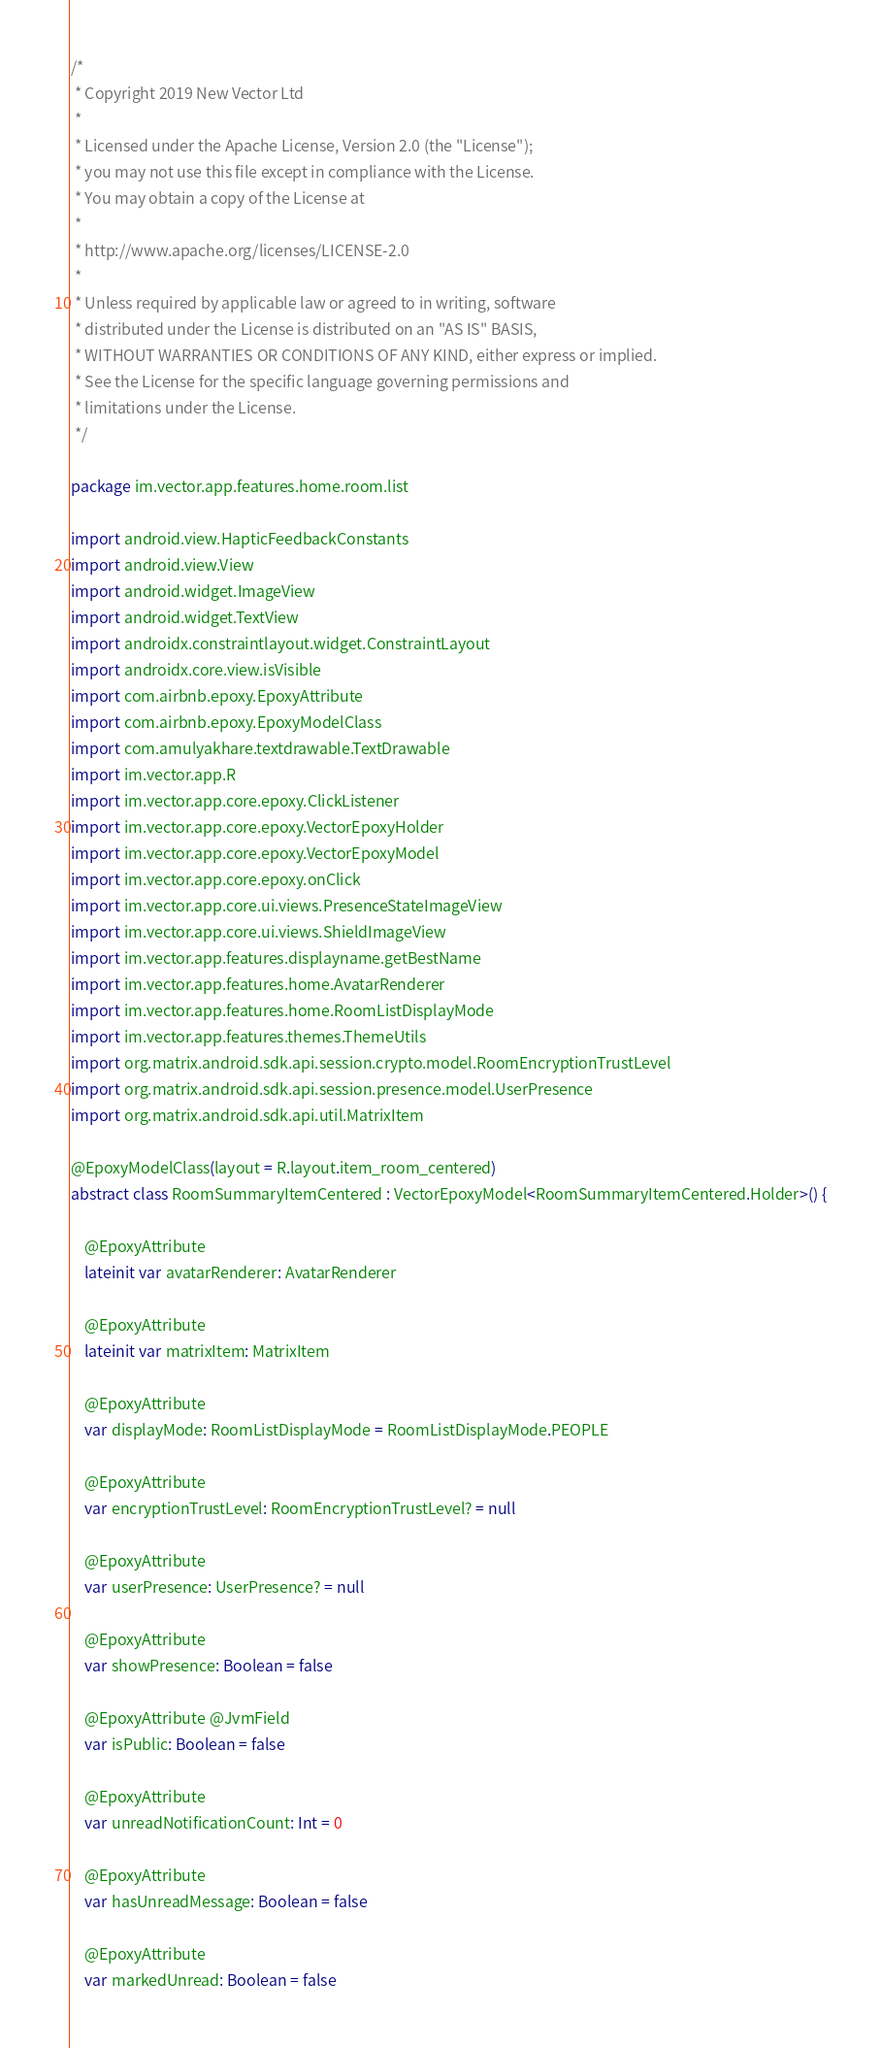<code> <loc_0><loc_0><loc_500><loc_500><_Kotlin_>/*
 * Copyright 2019 New Vector Ltd
 *
 * Licensed under the Apache License, Version 2.0 (the "License");
 * you may not use this file except in compliance with the License.
 * You may obtain a copy of the License at
 *
 * http://www.apache.org/licenses/LICENSE-2.0
 *
 * Unless required by applicable law or agreed to in writing, software
 * distributed under the License is distributed on an "AS IS" BASIS,
 * WITHOUT WARRANTIES OR CONDITIONS OF ANY KIND, either express or implied.
 * See the License for the specific language governing permissions and
 * limitations under the License.
 */

package im.vector.app.features.home.room.list

import android.view.HapticFeedbackConstants
import android.view.View
import android.widget.ImageView
import android.widget.TextView
import androidx.constraintlayout.widget.ConstraintLayout
import androidx.core.view.isVisible
import com.airbnb.epoxy.EpoxyAttribute
import com.airbnb.epoxy.EpoxyModelClass
import com.amulyakhare.textdrawable.TextDrawable
import im.vector.app.R
import im.vector.app.core.epoxy.ClickListener
import im.vector.app.core.epoxy.VectorEpoxyHolder
import im.vector.app.core.epoxy.VectorEpoxyModel
import im.vector.app.core.epoxy.onClick
import im.vector.app.core.ui.views.PresenceStateImageView
import im.vector.app.core.ui.views.ShieldImageView
import im.vector.app.features.displayname.getBestName
import im.vector.app.features.home.AvatarRenderer
import im.vector.app.features.home.RoomListDisplayMode
import im.vector.app.features.themes.ThemeUtils
import org.matrix.android.sdk.api.session.crypto.model.RoomEncryptionTrustLevel
import org.matrix.android.sdk.api.session.presence.model.UserPresence
import org.matrix.android.sdk.api.util.MatrixItem

@EpoxyModelClass(layout = R.layout.item_room_centered)
abstract class RoomSummaryItemCentered : VectorEpoxyModel<RoomSummaryItemCentered.Holder>() {

    @EpoxyAttribute
    lateinit var avatarRenderer: AvatarRenderer

    @EpoxyAttribute
    lateinit var matrixItem: MatrixItem

    @EpoxyAttribute
    var displayMode: RoomListDisplayMode = RoomListDisplayMode.PEOPLE

    @EpoxyAttribute
    var encryptionTrustLevel: RoomEncryptionTrustLevel? = null

    @EpoxyAttribute
    var userPresence: UserPresence? = null

    @EpoxyAttribute
    var showPresence: Boolean = false

    @EpoxyAttribute @JvmField
    var isPublic: Boolean = false

    @EpoxyAttribute
    var unreadNotificationCount: Int = 0

    @EpoxyAttribute
    var hasUnreadMessage: Boolean = false

    @EpoxyAttribute
    var markedUnread: Boolean = false
</code> 